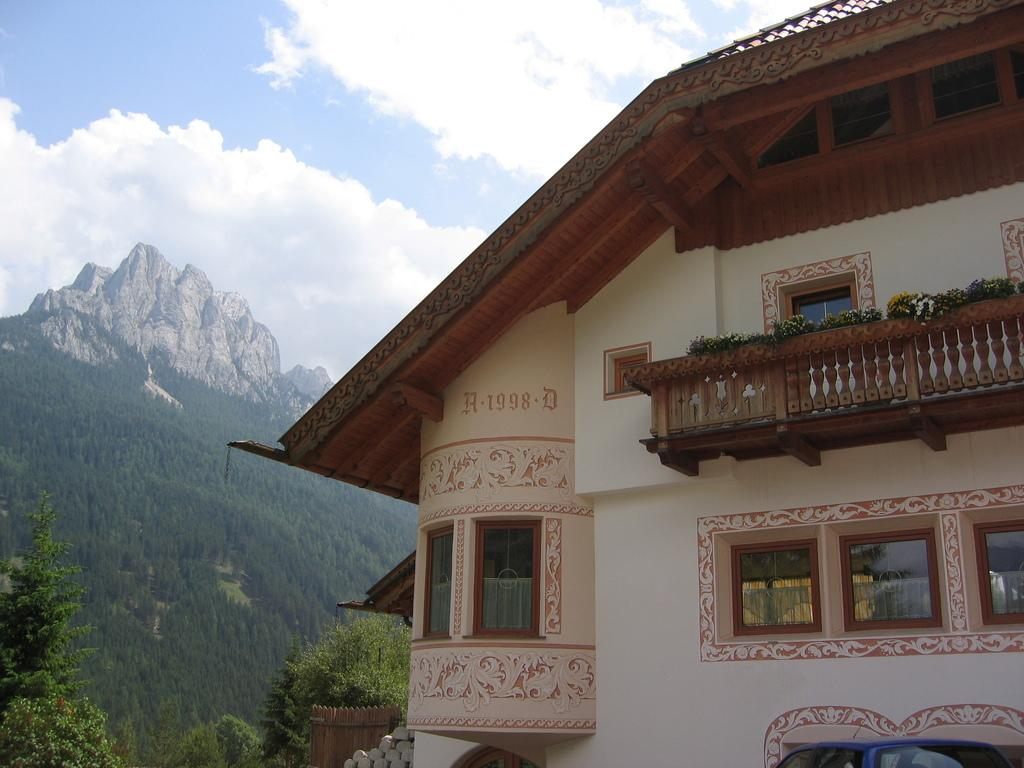What type of structure is present in the image? There is a building in the image. What can be seen surrounding the building? There is a fence and plants visible in the image. What architectural feature can be seen on the building? There are windows in the image. What type of natural elements are present in the image? There are trees and hills visible in the image. What is visible in the sky in the image? The sky is visible in the image, along with clouds. How many sisters are depicted in the image? There are no sisters present in the image; it features a building, fence, plants, windows, trees, hills, and the sky with clouds. What type of metal is used to construct the canvas in the image? There is no canvas or metal present in the image. 